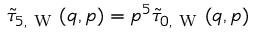<formula> <loc_0><loc_0><loc_500><loc_500>\tilde { \tau } _ { 5 , W } ( q , p ) = p ^ { 5 } \tilde { \tau } _ { 0 , W } ( q , p )</formula> 